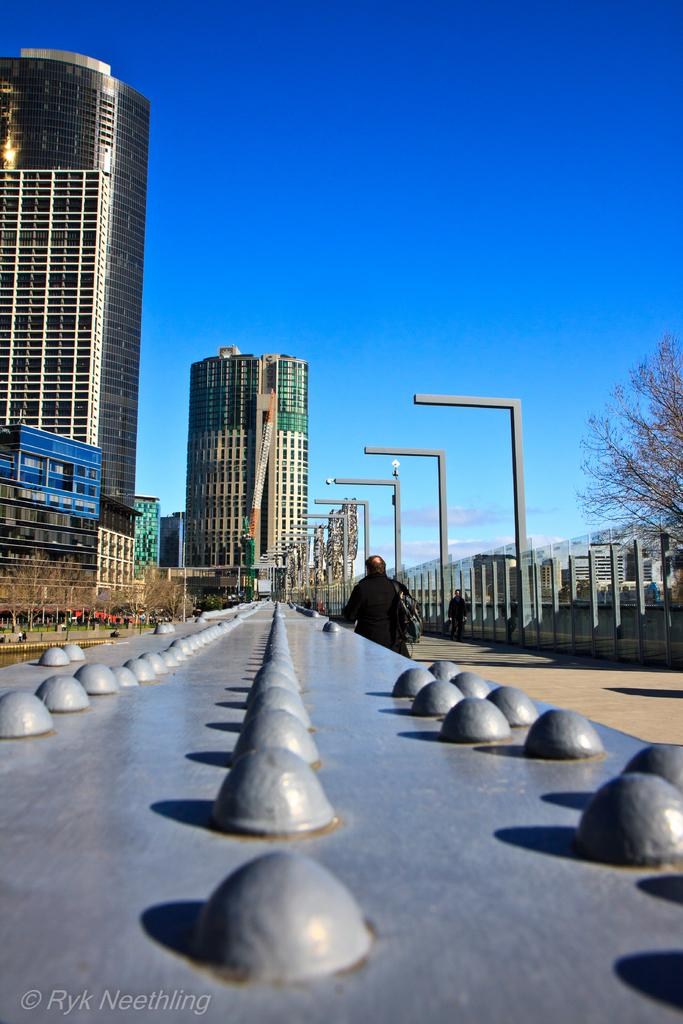What type of structures can be seen in the image? There are buildings in the image. What objects are present that might be used for supporting or holding something? There are poles in the image. What can be seen that might provide illumination? There are lights in the image. What type of natural or man-made objects can be seen on a surface in the image? There are rocks on a surface in the image. What type of living organism can be seen standing in the image? There is a person standing in the image. What type of vegetation can be seen in the image? There are trees in the image. What part of the natural environment is visible in the image? The sky is visible in the image. What type of stamp can be seen on the person's forehead in the image? There is no stamp present on the person's forehead in the image. What impulse might the person be experiencing while standing in the image? It is impossible to determine the person's emotions or impulses from the image alone. 